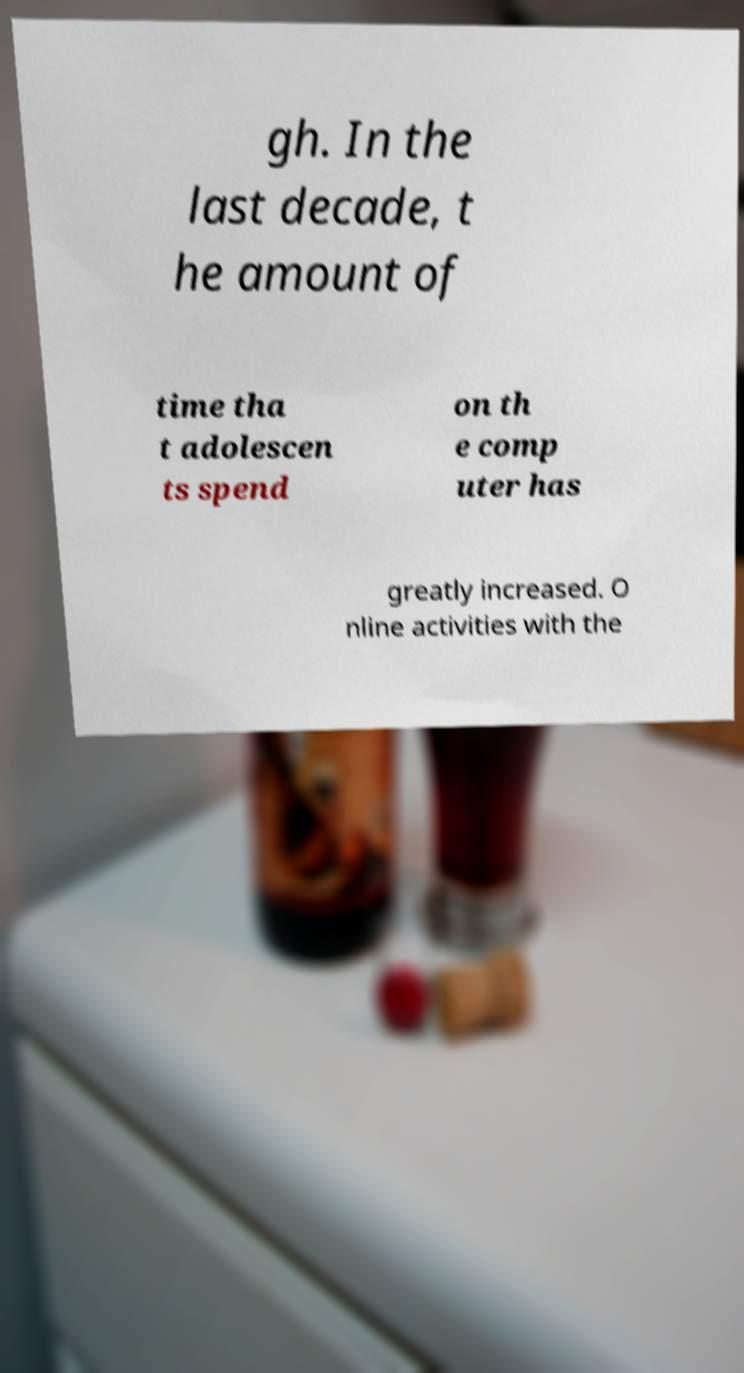There's text embedded in this image that I need extracted. Can you transcribe it verbatim? gh. In the last decade, t he amount of time tha t adolescen ts spend on th e comp uter has greatly increased. O nline activities with the 